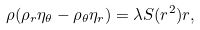<formula> <loc_0><loc_0><loc_500><loc_500>\rho ( \rho _ { r } \eta _ { \theta } - \rho _ { \theta } \eta _ { r } ) = \lambda S ( r ^ { 2 } ) r ,</formula> 